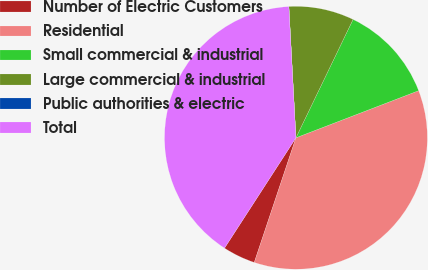<chart> <loc_0><loc_0><loc_500><loc_500><pie_chart><fcel>Number of Electric Customers<fcel>Residential<fcel>Small commercial & industrial<fcel>Large commercial & industrial<fcel>Public authorities & electric<fcel>Total<nl><fcel>4.01%<fcel>35.97%<fcel>12.01%<fcel>8.01%<fcel>0.01%<fcel>40.0%<nl></chart> 